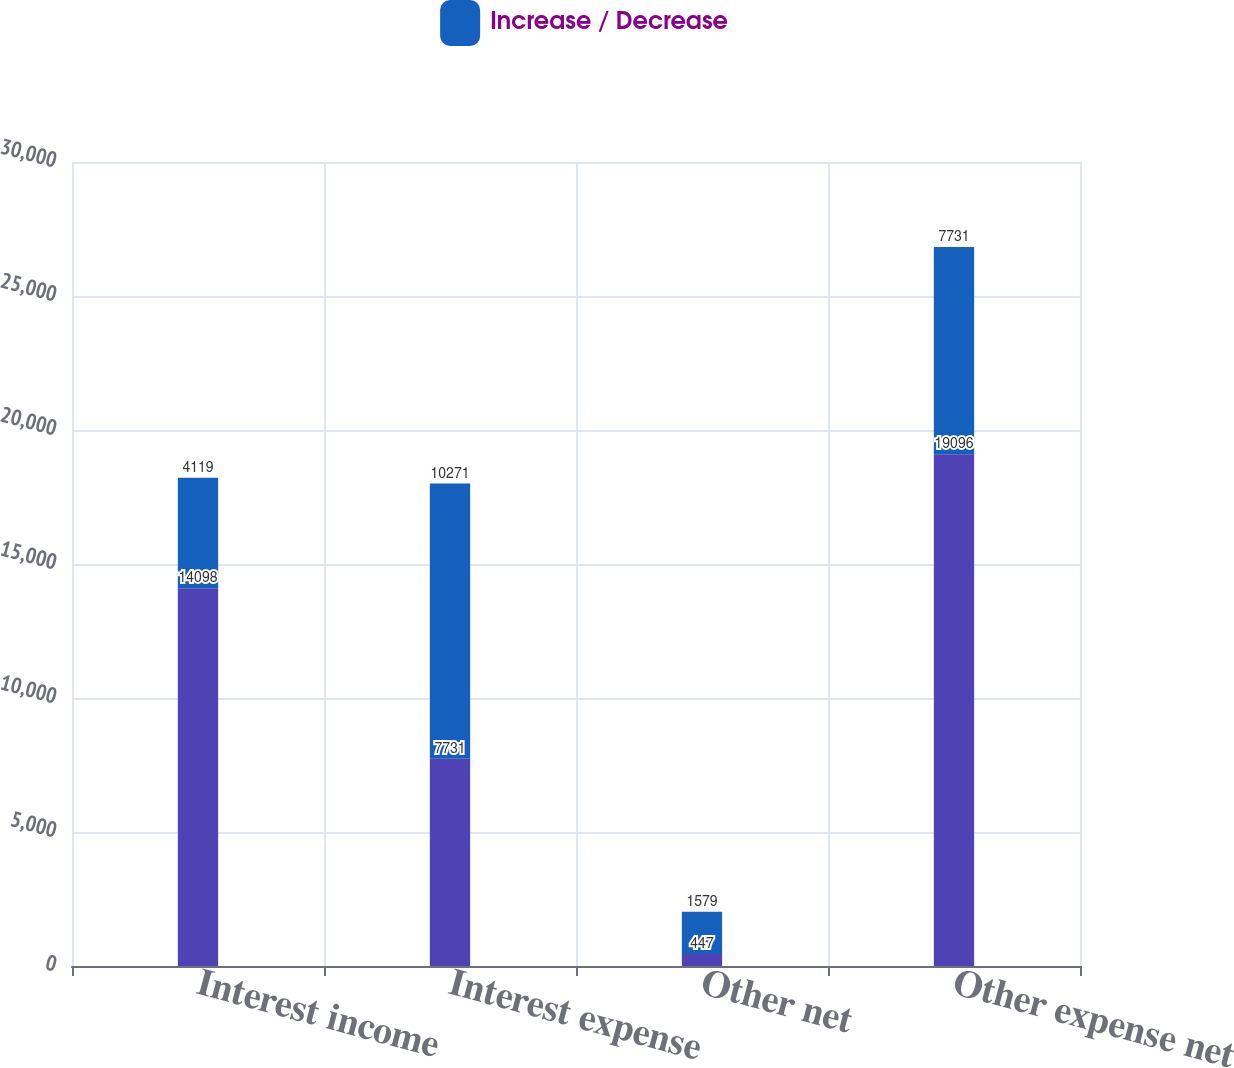Convert chart to OTSL. <chart><loc_0><loc_0><loc_500><loc_500><stacked_bar_chart><ecel><fcel>Interest income<fcel>Interest expense<fcel>Other net<fcel>Other expense net<nl><fcel>nan<fcel>14098<fcel>7731<fcel>447<fcel>19096<nl><fcel>Increase / Decrease<fcel>4119<fcel>10271<fcel>1579<fcel>7731<nl></chart> 